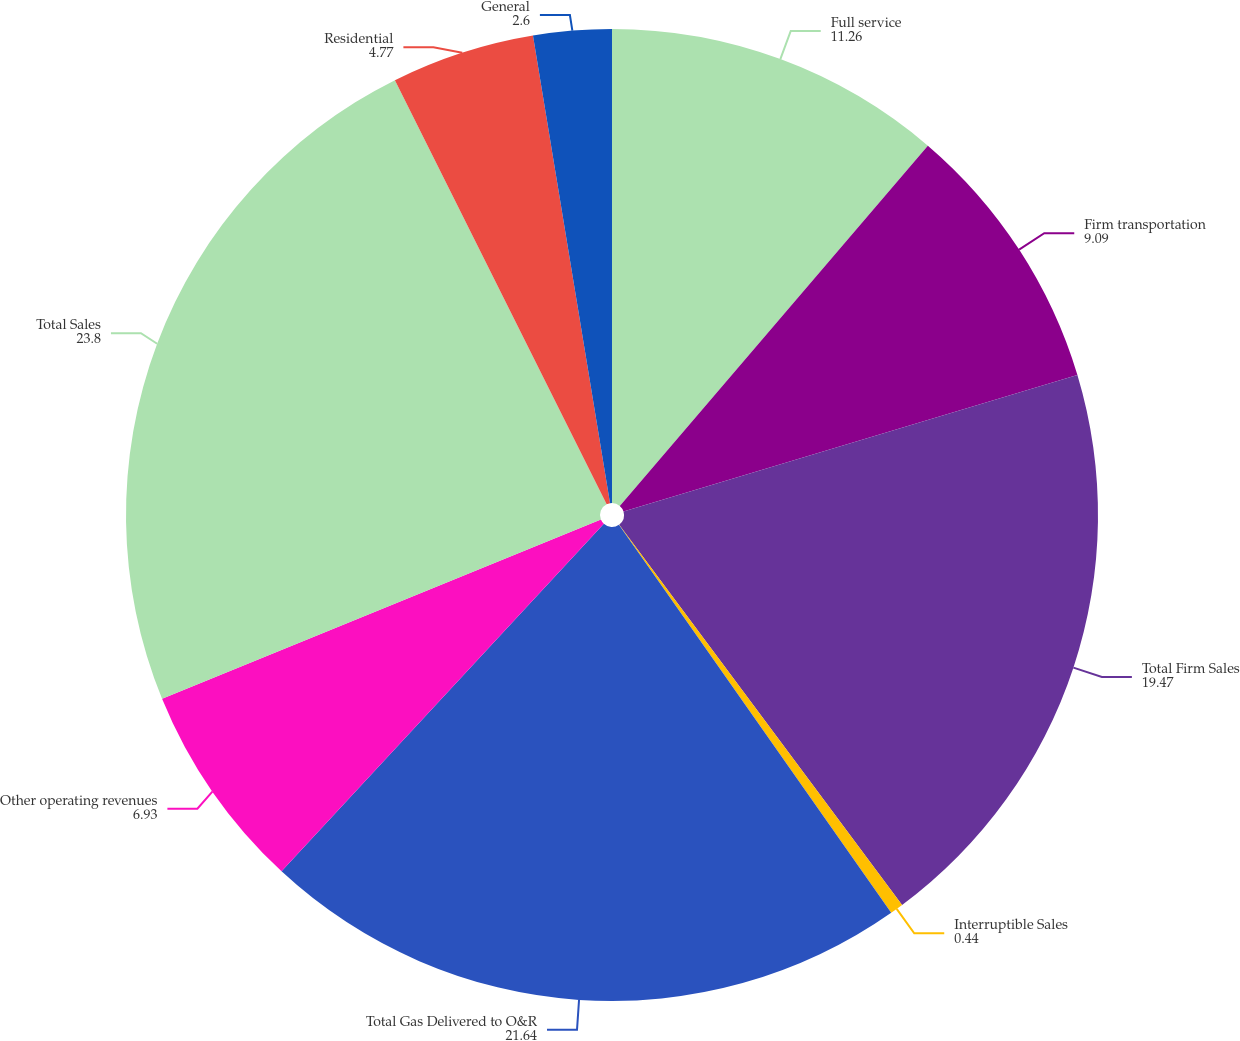<chart> <loc_0><loc_0><loc_500><loc_500><pie_chart><fcel>Full service<fcel>Firm transportation<fcel>Total Firm Sales<fcel>Interruptible Sales<fcel>Total Gas Delivered to O&R<fcel>Other operating revenues<fcel>Total Sales<fcel>Residential<fcel>General<nl><fcel>11.26%<fcel>9.09%<fcel>19.47%<fcel>0.44%<fcel>21.64%<fcel>6.93%<fcel>23.8%<fcel>4.77%<fcel>2.6%<nl></chart> 